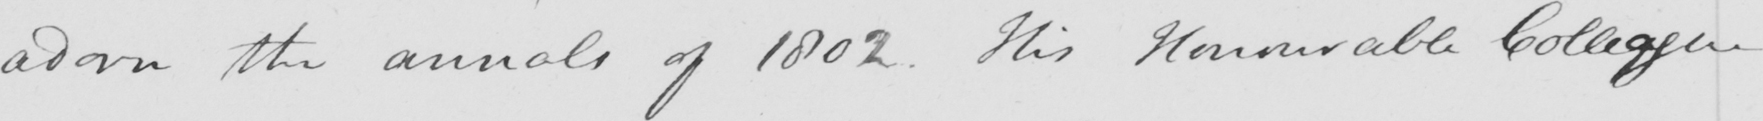What is written in this line of handwriting? adorn the annals of 1802 . This Honourable Colleague 